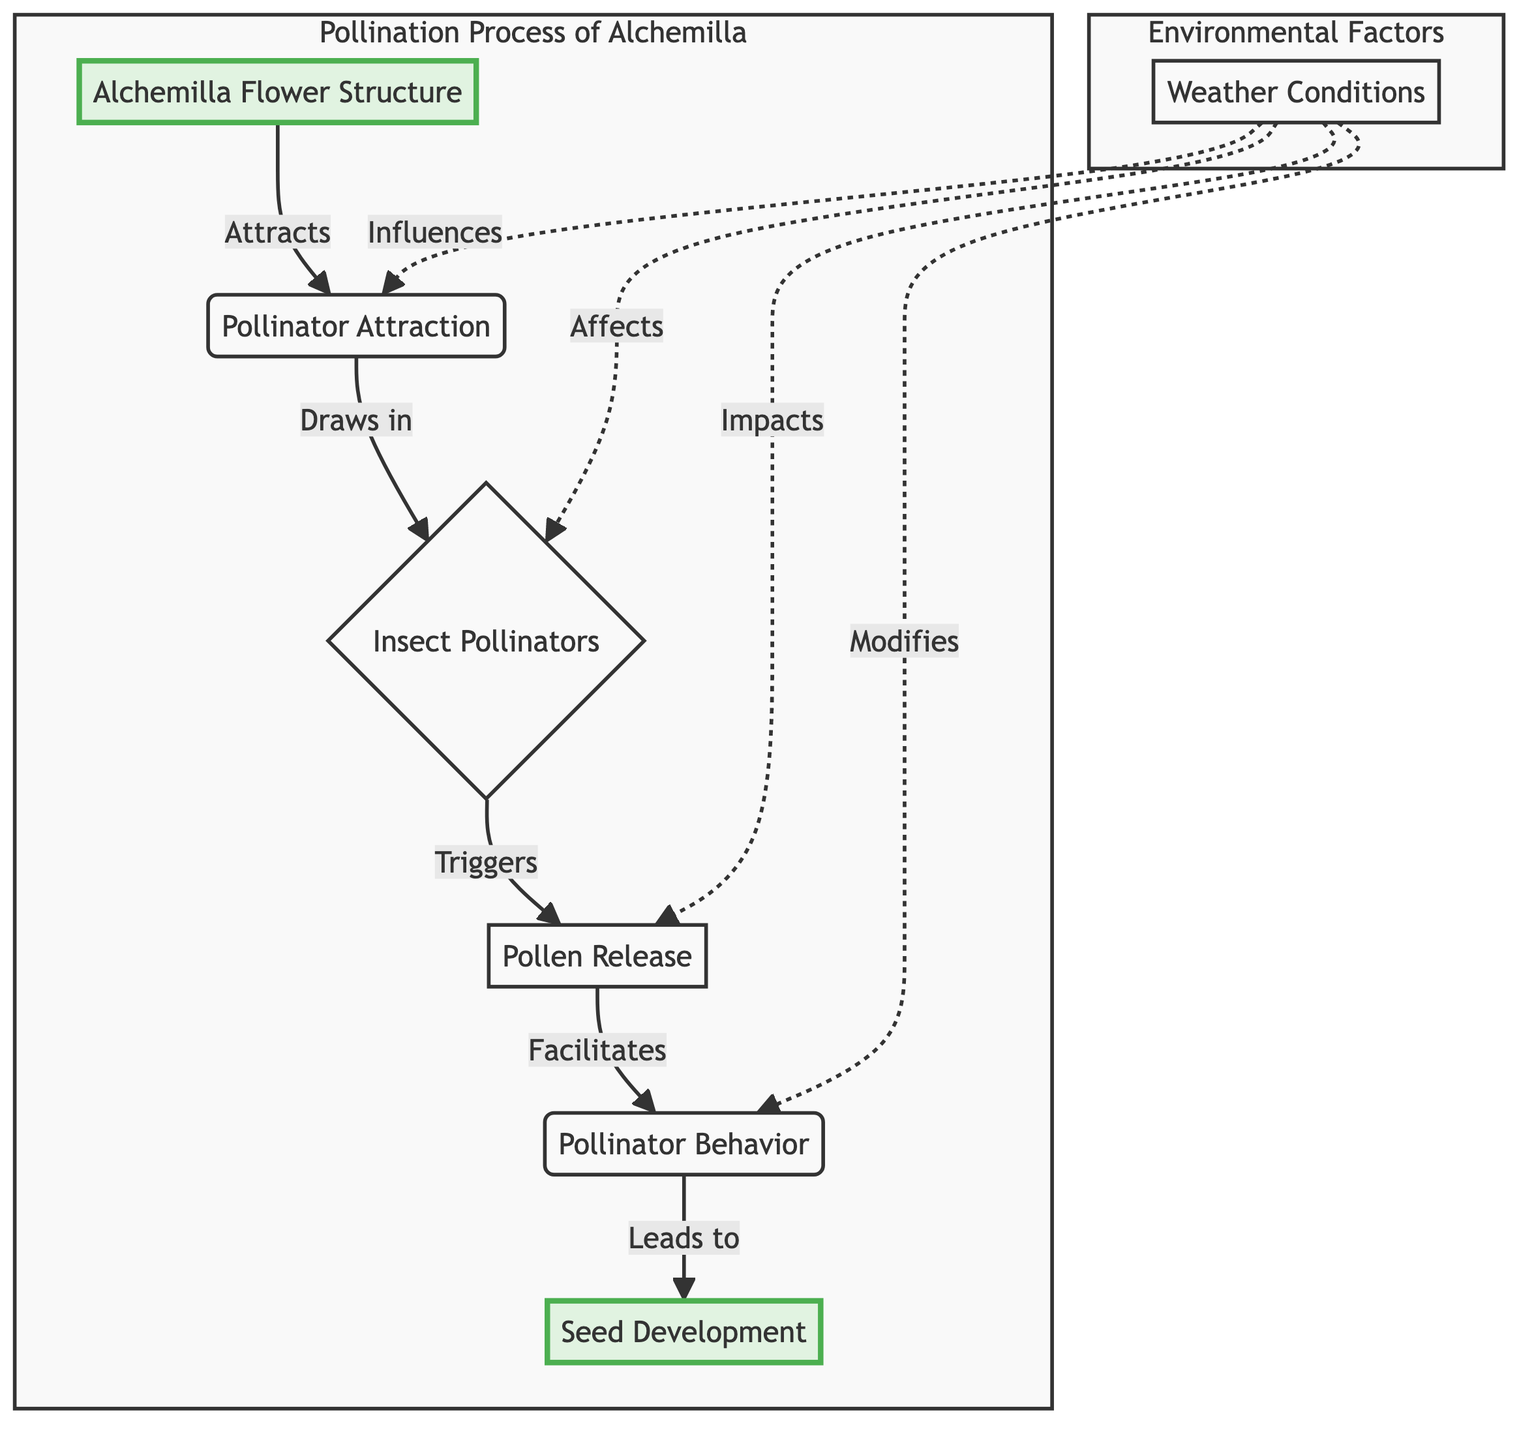What is the structure of Alchemilla flowers? The diagram states that Alchemilla flowers have a "Cup-shaped flowers with multiple small reproductive parts." This description can be found in the first node labeled "Alchemilla Flower Structure."
Answer: Cup-shaped flowers with multiple small reproductive parts Which pollinators are attracted to Alchemilla flowers? The diagram notes that "Insect Pollinators" include "Bees, butterflies, and other insects," which are listed in the node connected to "Pollinator Attraction."
Answer: Bees, butterflies, and other insects What does pollinator attraction lead to? The flowchart indicates that "Pollinator Attraction" leads to "Insect Pollinators" as an immediate outcome of attracting pollinators visually described in the diagram.
Answer: Insect Pollinators How many main processes are involved in the pollination of Alchemilla? There are six nodes representing the main processes in the chart: "Alchemilla Flower Structure," "Pollinator Attraction," "Insect Pollinators," "Pollen Release," "Pollinator Behavior," and "Seed Development." Counting these, we determine there are six main processes.
Answer: Six What factors influence pollinator attraction? The diagram shows "Weather Conditions" influencing "Pollinator Attraction." There is a line demonstrating this impact through a dashed connection in the Environmental Factors region.
Answer: Weather Conditions What happens after pollen is released? The diagram specifies that pollen release leads to "Pollinator Behavior," indicating that this stage is a direct result of the pollen being available for the pollinators to carry.
Answer: Pollinator Behavior Which environmental factor affects all steps of the pollination process? According to the diagram, "Weather Conditions" have connections to multiple parts of the process, influencing attraction, pollinators, pollen release, and behavior, demonstrating its overarching role.
Answer: Weather Conditions What is the ultimate outcome of successful pollination? The chart states that the "Seed Development" process is the end result of successful pollination, following the flow of pollen transfer and fertilization after pollinator behavior.
Answer: Seed Development What triggers pollen release? The diagram indicates that "Insect Pollinators" trigger "Pollen Release," as they facilitate the transfer of pollen while visiting the flowers for nectar, thus initiating this process.
Answer: Pollen Release How does weather affect pollinator behavior? The diagram shows a dashed line connecting "Weather Conditions" to "Pollinator Behavior," indicating that various weather factors can influence how pollinators act during pollination.
Answer: Affects 